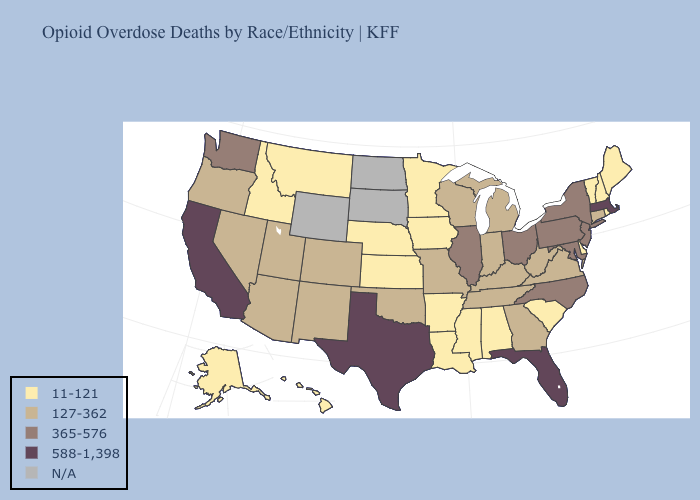Which states hav the highest value in the MidWest?
Concise answer only. Illinois, Ohio. What is the highest value in the USA?
Answer briefly. 588-1,398. What is the lowest value in the USA?
Quick response, please. 11-121. What is the highest value in states that border Oklahoma?
Keep it brief. 588-1,398. Which states have the highest value in the USA?
Short answer required. California, Florida, Massachusetts, Texas. What is the value of Ohio?
Short answer required. 365-576. Among the states that border Rhode Island , does Massachusetts have the highest value?
Answer briefly. Yes. Among the states that border Nebraska , does Colorado have the lowest value?
Be succinct. No. What is the lowest value in the West?
Quick response, please. 11-121. Does New York have the highest value in the Northeast?
Write a very short answer. No. Does Ohio have the highest value in the MidWest?
Keep it brief. Yes. Name the states that have a value in the range 11-121?
Concise answer only. Alabama, Alaska, Arkansas, Delaware, Hawaii, Idaho, Iowa, Kansas, Louisiana, Maine, Minnesota, Mississippi, Montana, Nebraska, New Hampshire, Rhode Island, South Carolina, Vermont. Which states hav the highest value in the MidWest?
Be succinct. Illinois, Ohio. What is the lowest value in the MidWest?
Be succinct. 11-121. 